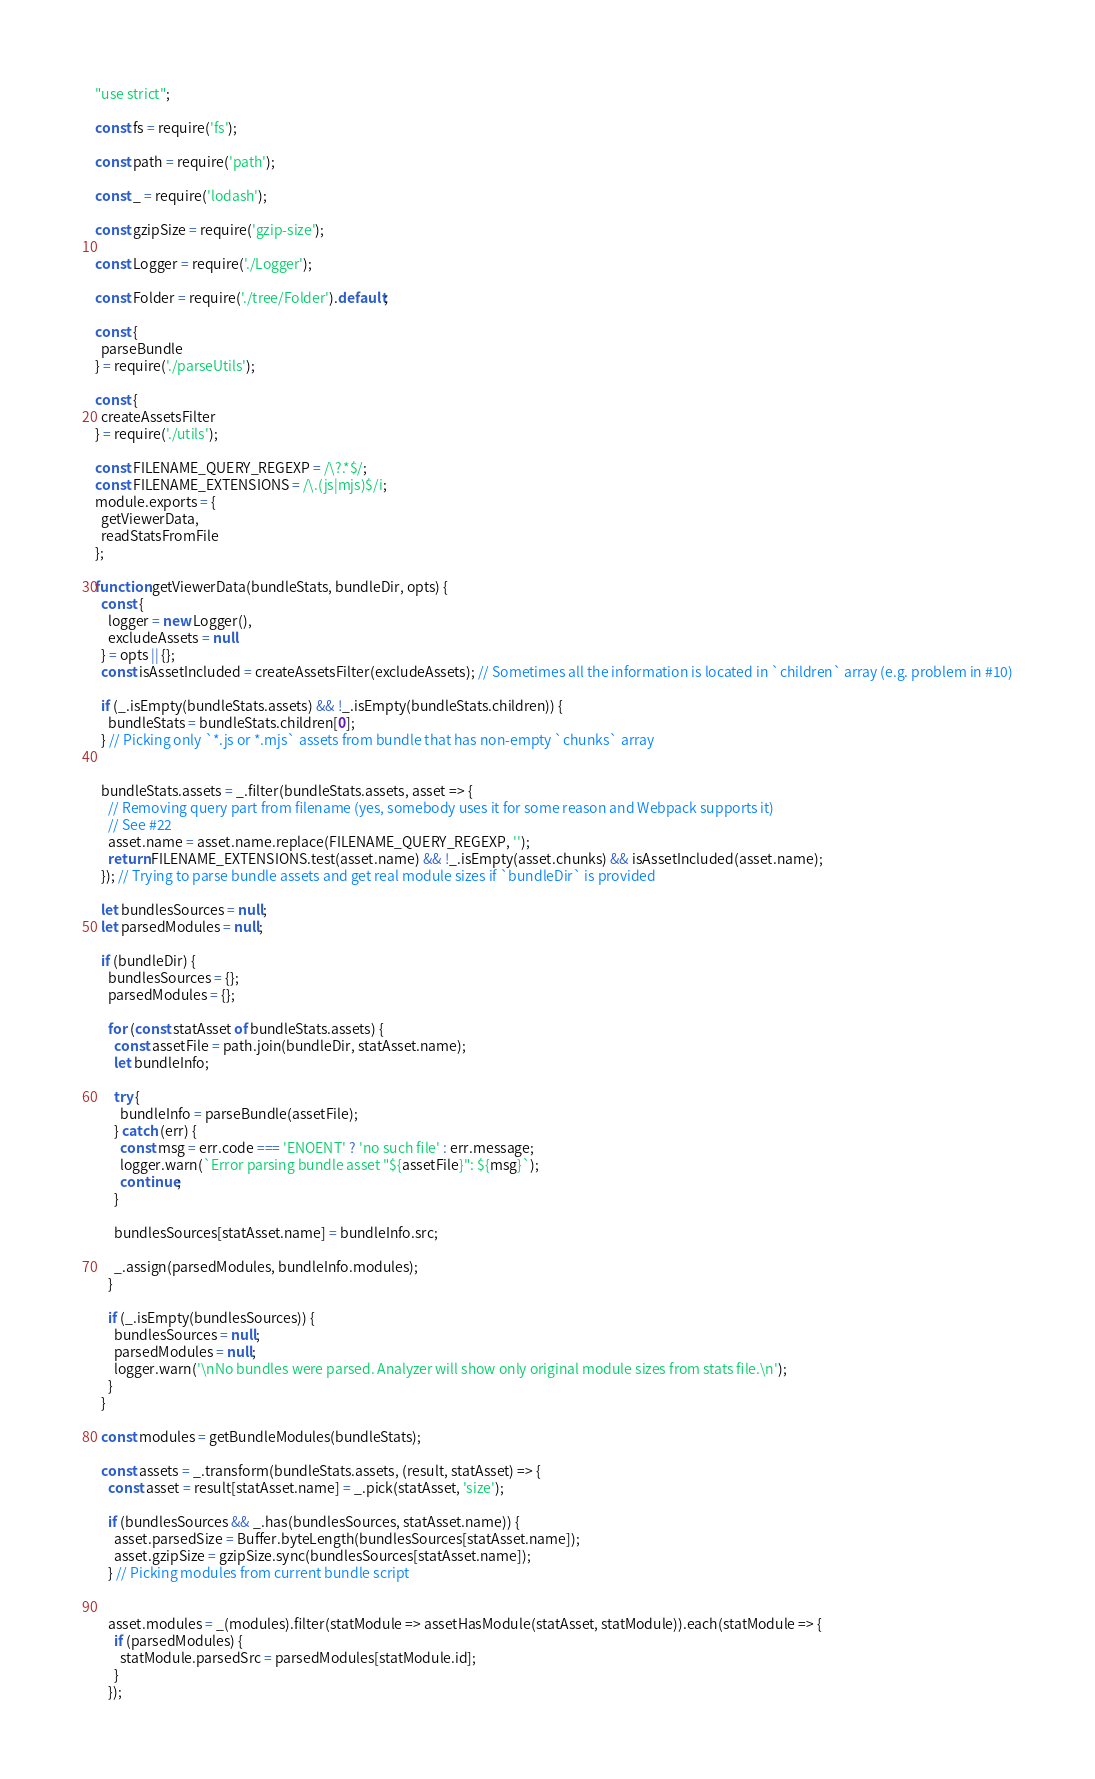Convert code to text. <code><loc_0><loc_0><loc_500><loc_500><_JavaScript_>"use strict";

const fs = require('fs');

const path = require('path');

const _ = require('lodash');

const gzipSize = require('gzip-size');

const Logger = require('./Logger');

const Folder = require('./tree/Folder').default;

const {
  parseBundle
} = require('./parseUtils');

const {
  createAssetsFilter
} = require('./utils');

const FILENAME_QUERY_REGEXP = /\?.*$/;
const FILENAME_EXTENSIONS = /\.(js|mjs)$/i;
module.exports = {
  getViewerData,
  readStatsFromFile
};

function getViewerData(bundleStats, bundleDir, opts) {
  const {
    logger = new Logger(),
    excludeAssets = null
  } = opts || {};
  const isAssetIncluded = createAssetsFilter(excludeAssets); // Sometimes all the information is located in `children` array (e.g. problem in #10)

  if (_.isEmpty(bundleStats.assets) && !_.isEmpty(bundleStats.children)) {
    bundleStats = bundleStats.children[0];
  } // Picking only `*.js or *.mjs` assets from bundle that has non-empty `chunks` array


  bundleStats.assets = _.filter(bundleStats.assets, asset => {
    // Removing query part from filename (yes, somebody uses it for some reason and Webpack supports it)
    // See #22
    asset.name = asset.name.replace(FILENAME_QUERY_REGEXP, '');
    return FILENAME_EXTENSIONS.test(asset.name) && !_.isEmpty(asset.chunks) && isAssetIncluded(asset.name);
  }); // Trying to parse bundle assets and get real module sizes if `bundleDir` is provided

  let bundlesSources = null;
  let parsedModules = null;

  if (bundleDir) {
    bundlesSources = {};
    parsedModules = {};

    for (const statAsset of bundleStats.assets) {
      const assetFile = path.join(bundleDir, statAsset.name);
      let bundleInfo;

      try {
        bundleInfo = parseBundle(assetFile);
      } catch (err) {
        const msg = err.code === 'ENOENT' ? 'no such file' : err.message;
        logger.warn(`Error parsing bundle asset "${assetFile}": ${msg}`);
        continue;
      }

      bundlesSources[statAsset.name] = bundleInfo.src;

      _.assign(parsedModules, bundleInfo.modules);
    }

    if (_.isEmpty(bundlesSources)) {
      bundlesSources = null;
      parsedModules = null;
      logger.warn('\nNo bundles were parsed. Analyzer will show only original module sizes from stats file.\n');
    }
  }

  const modules = getBundleModules(bundleStats);

  const assets = _.transform(bundleStats.assets, (result, statAsset) => {
    const asset = result[statAsset.name] = _.pick(statAsset, 'size');

    if (bundlesSources && _.has(bundlesSources, statAsset.name)) {
      asset.parsedSize = Buffer.byteLength(bundlesSources[statAsset.name]);
      asset.gzipSize = gzipSize.sync(bundlesSources[statAsset.name]);
    } // Picking modules from current bundle script


    asset.modules = _(modules).filter(statModule => assetHasModule(statAsset, statModule)).each(statModule => {
      if (parsedModules) {
        statModule.parsedSrc = parsedModules[statModule.id];
      }
    });</code> 